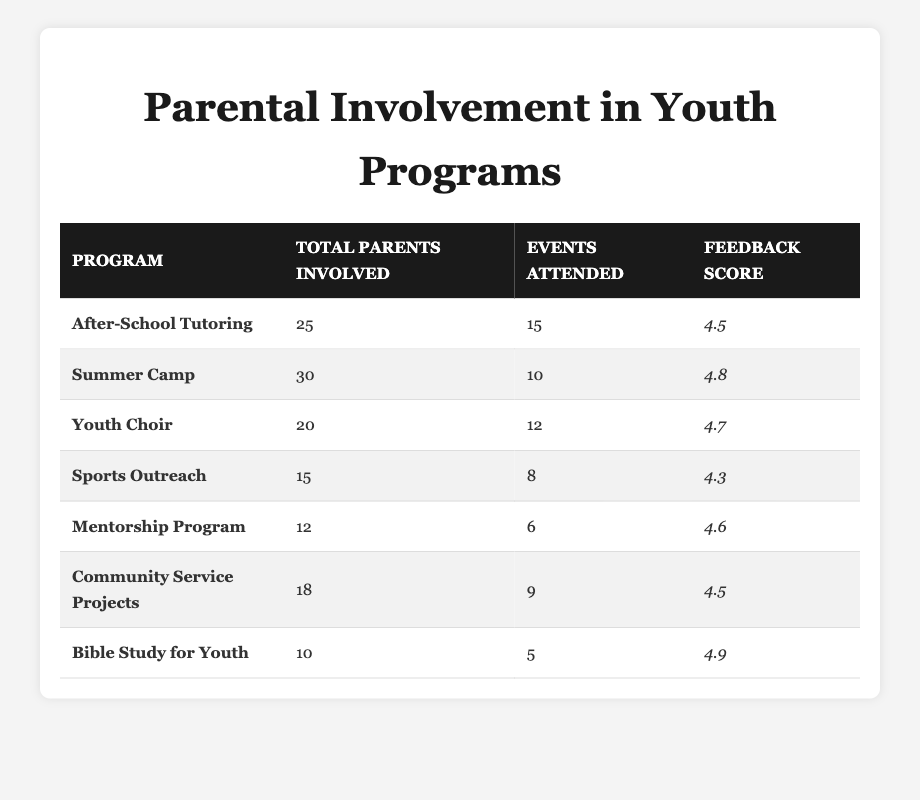What is the total number of parents involved in the Summer Camp program? The table shows that the Summer Camp program has a total of 30 parents involved.
Answer: 30 Which program had the highest feedback score? By comparing the feedback scores listed in the table, the Bible Study for Youth program has the highest score of 4.9.
Answer: Bible Study for Youth How many events did the Youth Choir parents attend in total? According to the table, the Youth Choir program had 12 events attended by parents.
Answer: 12 What is the overall average feedback score of all programs? The feedback scores are 4.5, 4.8, 4.7, 4.3, 4.6, 4.5, and 4.9. Adding these scores gives 30.3, and dividing by 7 (the number of programs) results in an average of approximately 4.34.
Answer: 4.34 Did more than 20 parents participate in the Sports Outreach program? The table indicates that 15 parents were involved in the Sports Outreach program, which is fewer than 20.
Answer: No What is the difference between the total number of parents involved in After-School Tutoring and Mentorship Program? The After-School Tutoring program has 25 parents involved, while the Mentorship Program has 12. The difference is 25 - 12 = 13.
Answer: 13 Which program had the least number of events attended and what was the count? The Mentorship Program had the least number of events attended at 6.
Answer: 6 If we consider the Bible Study for Youth program, what percentage of the total parents involved across all programs does this represent? The total parents involved across all programs is 25 + 30 + 20 + 15 + 12 + 18 + 10 = 130. The Bible Study for Youth has 10 parents involved, so the percentage is (10/130) * 100 = 7.69%.
Answer: 7.69% Which program had a feedback score lower than 4.5? By reviewing the feedback scores in the table, the Sports Outreach program had a score of 4.3, which is lower than 4.5.
Answer: Sports Outreach How many more parents participated in the Summer Camp than in the Youth Choir? The Summer Camp had 30 parents involved, and the Youth Choir had 20. The difference is 30 - 20 = 10.
Answer: 10 